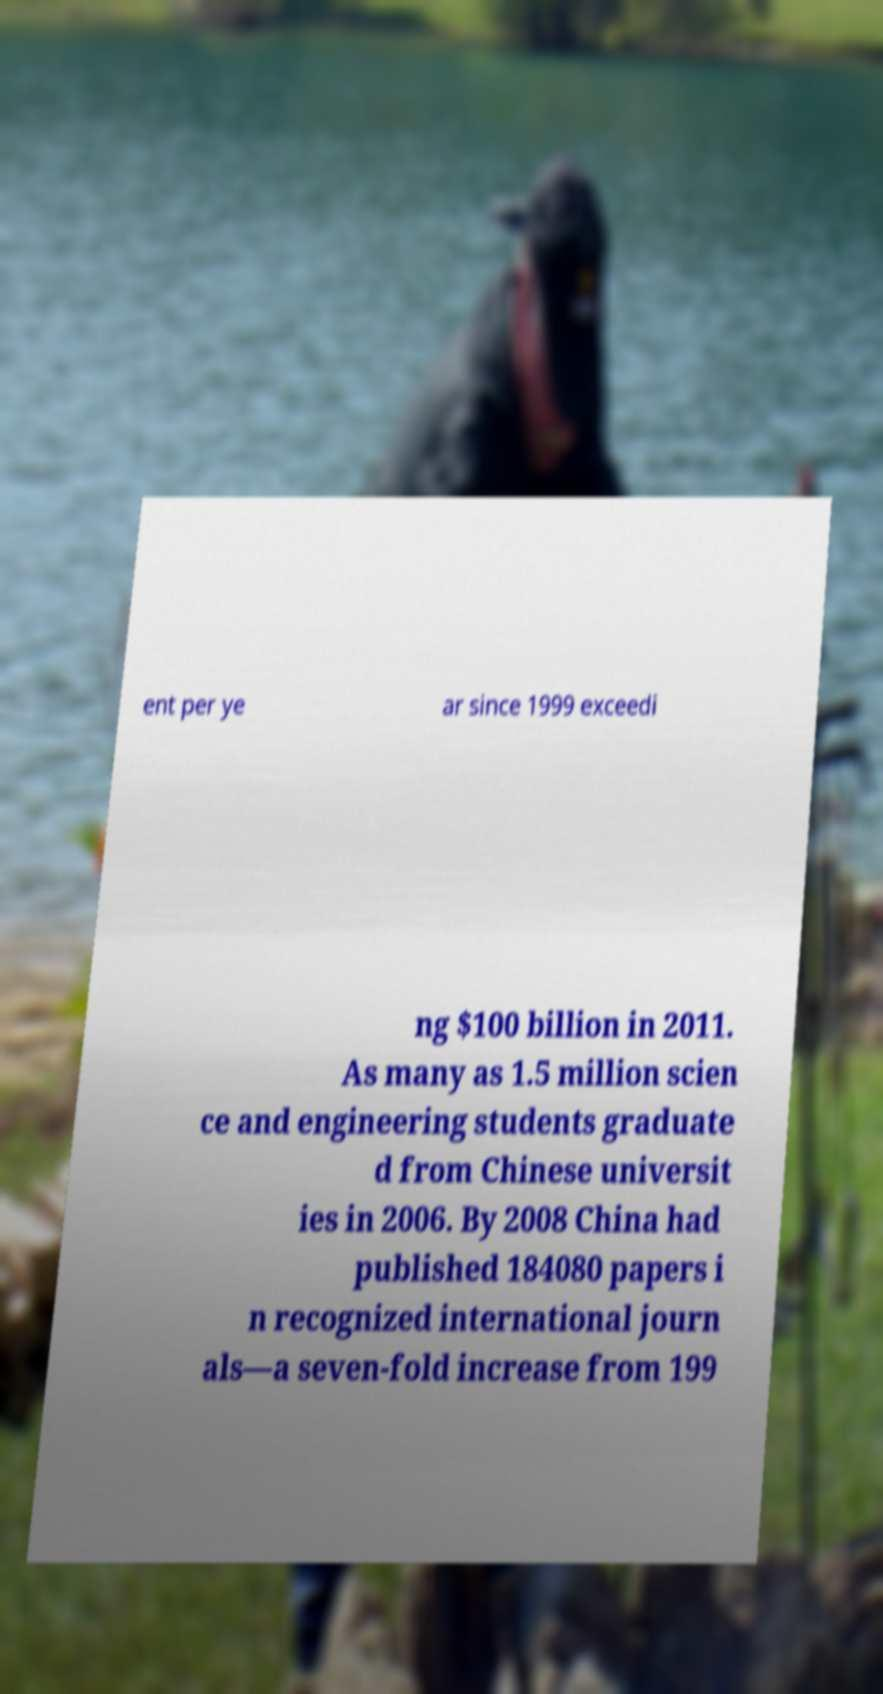Could you assist in decoding the text presented in this image and type it out clearly? ent per ye ar since 1999 exceedi ng $100 billion in 2011. As many as 1.5 million scien ce and engineering students graduate d from Chinese universit ies in 2006. By 2008 China had published 184080 papers i n recognized international journ als—a seven-fold increase from 199 